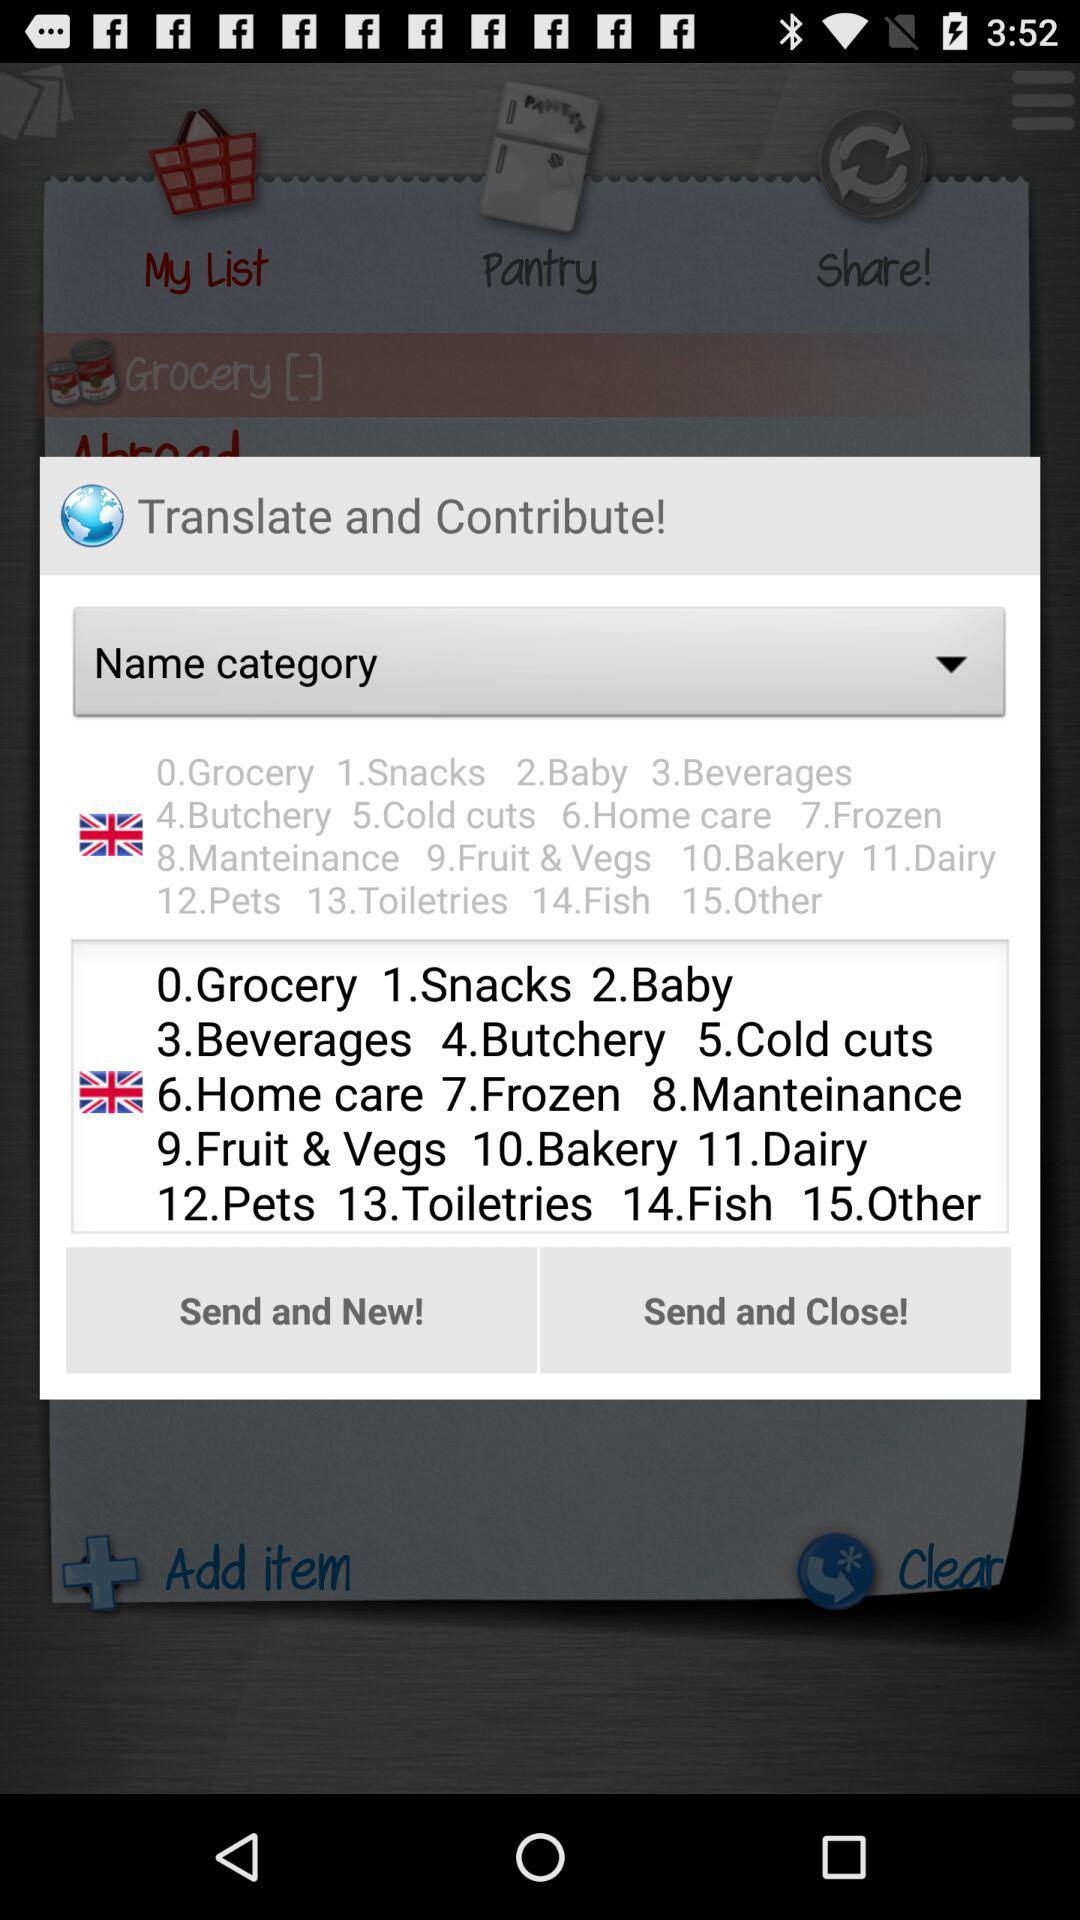How many categories are available to choose from?
Answer the question using a single word or phrase. 15 